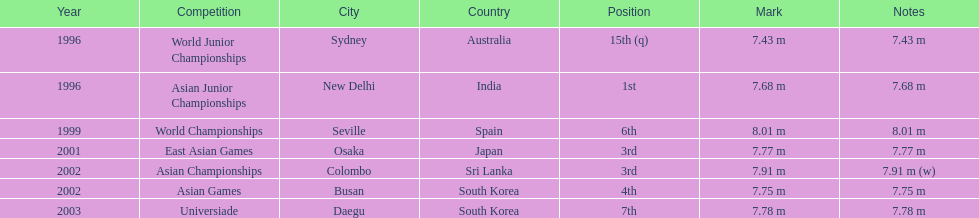What was the venue when he placed first? New Delhi, India. 